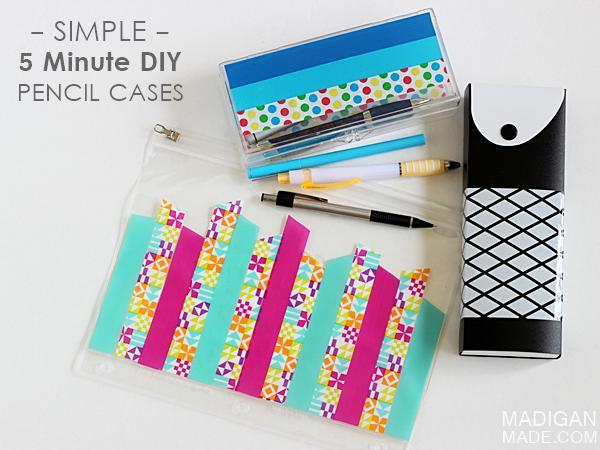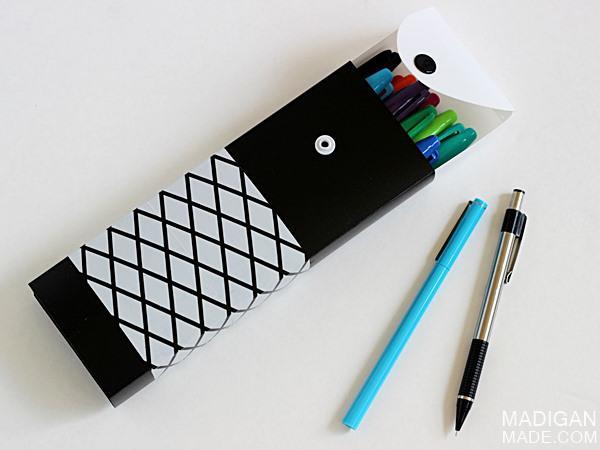The first image is the image on the left, the second image is the image on the right. Considering the images on both sides, is "There is a zipper in the image on the right." valid? Answer yes or no. No. 